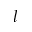<formula> <loc_0><loc_0><loc_500><loc_500>l</formula> 